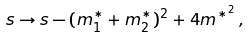Convert formula to latex. <formula><loc_0><loc_0><loc_500><loc_500>s \rightarrow s - ( m _ { 1 } ^ { * } + m _ { 2 } ^ { * } ) ^ { 2 } + 4 m ^ { * ^ { 2 } } \, ,</formula> 